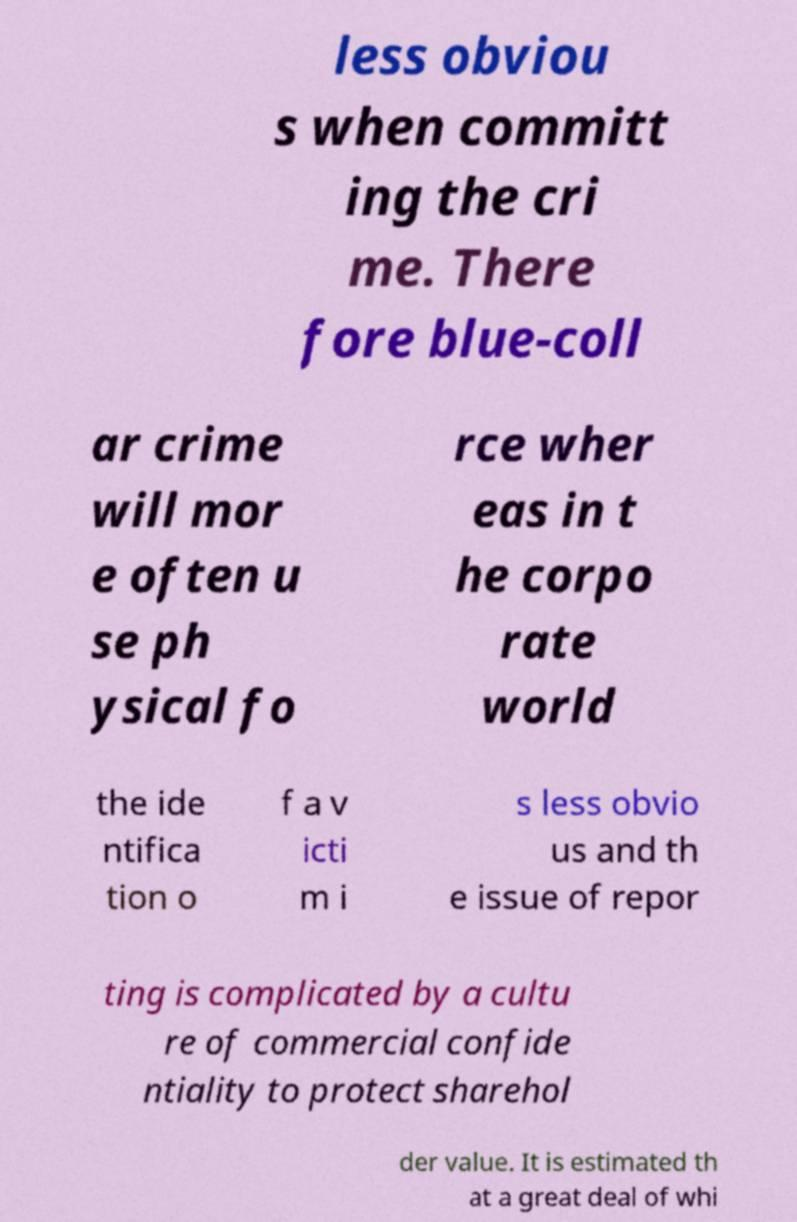There's text embedded in this image that I need extracted. Can you transcribe it verbatim? less obviou s when committ ing the cri me. There fore blue-coll ar crime will mor e often u se ph ysical fo rce wher eas in t he corpo rate world the ide ntifica tion o f a v icti m i s less obvio us and th e issue of repor ting is complicated by a cultu re of commercial confide ntiality to protect sharehol der value. It is estimated th at a great deal of whi 